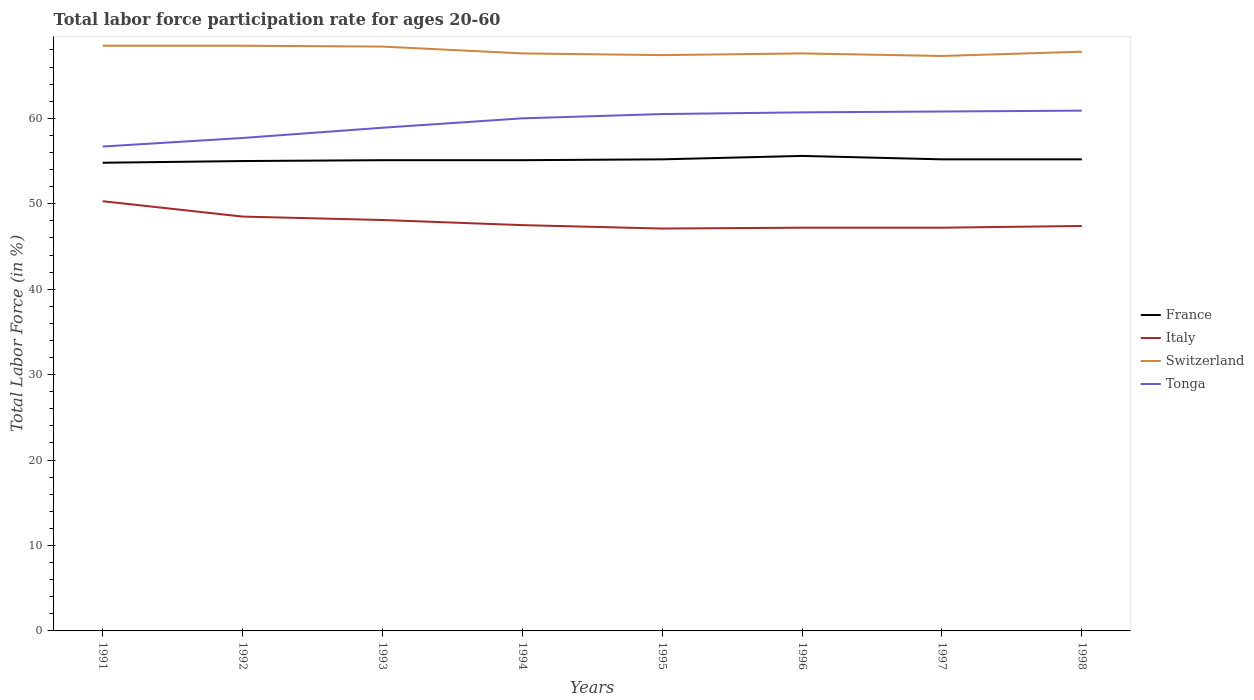Across all years, what is the maximum labor force participation rate in France?
Provide a short and direct response. 54.8. What is the total labor force participation rate in Switzerland in the graph?
Make the answer very short. -0.2. What is the difference between the highest and the second highest labor force participation rate in Switzerland?
Make the answer very short. 1.2. What is the difference between the highest and the lowest labor force participation rate in France?
Your answer should be compact. 4. Is the labor force participation rate in France strictly greater than the labor force participation rate in Italy over the years?
Provide a short and direct response. No. How many lines are there?
Your answer should be very brief. 4. What is the difference between two consecutive major ticks on the Y-axis?
Give a very brief answer. 10. Does the graph contain any zero values?
Your response must be concise. No. Where does the legend appear in the graph?
Your response must be concise. Center right. What is the title of the graph?
Make the answer very short. Total labor force participation rate for ages 20-60. What is the label or title of the X-axis?
Make the answer very short. Years. What is the label or title of the Y-axis?
Your answer should be compact. Total Labor Force (in %). What is the Total Labor Force (in %) in France in 1991?
Make the answer very short. 54.8. What is the Total Labor Force (in %) in Italy in 1991?
Provide a short and direct response. 50.3. What is the Total Labor Force (in %) of Switzerland in 1991?
Offer a very short reply. 68.5. What is the Total Labor Force (in %) of Tonga in 1991?
Make the answer very short. 56.7. What is the Total Labor Force (in %) of Italy in 1992?
Provide a short and direct response. 48.5. What is the Total Labor Force (in %) in Switzerland in 1992?
Keep it short and to the point. 68.5. What is the Total Labor Force (in %) in Tonga in 1992?
Offer a very short reply. 57.7. What is the Total Labor Force (in %) in France in 1993?
Your answer should be compact. 55.1. What is the Total Labor Force (in %) of Italy in 1993?
Offer a terse response. 48.1. What is the Total Labor Force (in %) of Switzerland in 1993?
Your response must be concise. 68.4. What is the Total Labor Force (in %) in Tonga in 1993?
Your response must be concise. 58.9. What is the Total Labor Force (in %) in France in 1994?
Provide a short and direct response. 55.1. What is the Total Labor Force (in %) in Italy in 1994?
Ensure brevity in your answer.  47.5. What is the Total Labor Force (in %) in Switzerland in 1994?
Make the answer very short. 67.6. What is the Total Labor Force (in %) in France in 1995?
Provide a succinct answer. 55.2. What is the Total Labor Force (in %) in Italy in 1995?
Offer a terse response. 47.1. What is the Total Labor Force (in %) of Switzerland in 1995?
Offer a terse response. 67.4. What is the Total Labor Force (in %) in Tonga in 1995?
Make the answer very short. 60.5. What is the Total Labor Force (in %) of France in 1996?
Provide a short and direct response. 55.6. What is the Total Labor Force (in %) in Italy in 1996?
Your answer should be very brief. 47.2. What is the Total Labor Force (in %) in Switzerland in 1996?
Your answer should be very brief. 67.6. What is the Total Labor Force (in %) of Tonga in 1996?
Give a very brief answer. 60.7. What is the Total Labor Force (in %) in France in 1997?
Offer a terse response. 55.2. What is the Total Labor Force (in %) in Italy in 1997?
Give a very brief answer. 47.2. What is the Total Labor Force (in %) of Switzerland in 1997?
Your response must be concise. 67.3. What is the Total Labor Force (in %) of Tonga in 1997?
Offer a very short reply. 60.8. What is the Total Labor Force (in %) of France in 1998?
Provide a succinct answer. 55.2. What is the Total Labor Force (in %) in Italy in 1998?
Your answer should be compact. 47.4. What is the Total Labor Force (in %) in Switzerland in 1998?
Your response must be concise. 67.8. What is the Total Labor Force (in %) of Tonga in 1998?
Ensure brevity in your answer.  60.9. Across all years, what is the maximum Total Labor Force (in %) of France?
Keep it short and to the point. 55.6. Across all years, what is the maximum Total Labor Force (in %) of Italy?
Give a very brief answer. 50.3. Across all years, what is the maximum Total Labor Force (in %) in Switzerland?
Provide a succinct answer. 68.5. Across all years, what is the maximum Total Labor Force (in %) of Tonga?
Offer a very short reply. 60.9. Across all years, what is the minimum Total Labor Force (in %) of France?
Ensure brevity in your answer.  54.8. Across all years, what is the minimum Total Labor Force (in %) of Italy?
Ensure brevity in your answer.  47.1. Across all years, what is the minimum Total Labor Force (in %) in Switzerland?
Offer a terse response. 67.3. Across all years, what is the minimum Total Labor Force (in %) in Tonga?
Give a very brief answer. 56.7. What is the total Total Labor Force (in %) of France in the graph?
Make the answer very short. 441.2. What is the total Total Labor Force (in %) in Italy in the graph?
Your answer should be very brief. 383.3. What is the total Total Labor Force (in %) in Switzerland in the graph?
Make the answer very short. 543.1. What is the total Total Labor Force (in %) in Tonga in the graph?
Keep it short and to the point. 476.2. What is the difference between the Total Labor Force (in %) of France in 1991 and that in 1992?
Keep it short and to the point. -0.2. What is the difference between the Total Labor Force (in %) in Italy in 1991 and that in 1992?
Ensure brevity in your answer.  1.8. What is the difference between the Total Labor Force (in %) of France in 1991 and that in 1993?
Your response must be concise. -0.3. What is the difference between the Total Labor Force (in %) of Tonga in 1991 and that in 1993?
Keep it short and to the point. -2.2. What is the difference between the Total Labor Force (in %) in France in 1991 and that in 1994?
Your answer should be compact. -0.3. What is the difference between the Total Labor Force (in %) of Italy in 1991 and that in 1995?
Offer a terse response. 3.2. What is the difference between the Total Labor Force (in %) of Switzerland in 1991 and that in 1995?
Your answer should be compact. 1.1. What is the difference between the Total Labor Force (in %) of France in 1991 and that in 1996?
Ensure brevity in your answer.  -0.8. What is the difference between the Total Labor Force (in %) of Italy in 1991 and that in 1996?
Give a very brief answer. 3.1. What is the difference between the Total Labor Force (in %) of Italy in 1991 and that in 1997?
Offer a terse response. 3.1. What is the difference between the Total Labor Force (in %) in Switzerland in 1991 and that in 1997?
Provide a short and direct response. 1.2. What is the difference between the Total Labor Force (in %) in Tonga in 1991 and that in 1997?
Keep it short and to the point. -4.1. What is the difference between the Total Labor Force (in %) in Switzerland in 1991 and that in 1998?
Give a very brief answer. 0.7. What is the difference between the Total Labor Force (in %) in Tonga in 1991 and that in 1998?
Provide a succinct answer. -4.2. What is the difference between the Total Labor Force (in %) in France in 1992 and that in 1993?
Your response must be concise. -0.1. What is the difference between the Total Labor Force (in %) of Italy in 1992 and that in 1994?
Your answer should be very brief. 1. What is the difference between the Total Labor Force (in %) of Tonga in 1992 and that in 1994?
Make the answer very short. -2.3. What is the difference between the Total Labor Force (in %) of France in 1992 and that in 1995?
Make the answer very short. -0.2. What is the difference between the Total Labor Force (in %) of France in 1992 and that in 1996?
Your answer should be very brief. -0.6. What is the difference between the Total Labor Force (in %) in Italy in 1992 and that in 1996?
Provide a short and direct response. 1.3. What is the difference between the Total Labor Force (in %) of Switzerland in 1992 and that in 1996?
Your answer should be compact. 0.9. What is the difference between the Total Labor Force (in %) in Italy in 1992 and that in 1997?
Your answer should be compact. 1.3. What is the difference between the Total Labor Force (in %) in Switzerland in 1992 and that in 1997?
Offer a very short reply. 1.2. What is the difference between the Total Labor Force (in %) of France in 1992 and that in 1998?
Keep it short and to the point. -0.2. What is the difference between the Total Labor Force (in %) of Italy in 1992 and that in 1998?
Ensure brevity in your answer.  1.1. What is the difference between the Total Labor Force (in %) in Switzerland in 1992 and that in 1998?
Offer a very short reply. 0.7. What is the difference between the Total Labor Force (in %) of Tonga in 1992 and that in 1998?
Ensure brevity in your answer.  -3.2. What is the difference between the Total Labor Force (in %) of France in 1993 and that in 1994?
Make the answer very short. 0. What is the difference between the Total Labor Force (in %) of Italy in 1993 and that in 1994?
Make the answer very short. 0.6. What is the difference between the Total Labor Force (in %) in Switzerland in 1993 and that in 1994?
Ensure brevity in your answer.  0.8. What is the difference between the Total Labor Force (in %) of France in 1993 and that in 1996?
Give a very brief answer. -0.5. What is the difference between the Total Labor Force (in %) in Italy in 1993 and that in 1996?
Give a very brief answer. 0.9. What is the difference between the Total Labor Force (in %) in Tonga in 1993 and that in 1996?
Offer a terse response. -1.8. What is the difference between the Total Labor Force (in %) in France in 1993 and that in 1997?
Offer a terse response. -0.1. What is the difference between the Total Labor Force (in %) of Switzerland in 1993 and that in 1997?
Offer a terse response. 1.1. What is the difference between the Total Labor Force (in %) of Tonga in 1993 and that in 1997?
Your answer should be compact. -1.9. What is the difference between the Total Labor Force (in %) in Italy in 1993 and that in 1998?
Your answer should be very brief. 0.7. What is the difference between the Total Labor Force (in %) of France in 1994 and that in 1995?
Offer a very short reply. -0.1. What is the difference between the Total Labor Force (in %) of Italy in 1994 and that in 1995?
Offer a terse response. 0.4. What is the difference between the Total Labor Force (in %) of Switzerland in 1994 and that in 1995?
Offer a very short reply. 0.2. What is the difference between the Total Labor Force (in %) of Tonga in 1994 and that in 1995?
Provide a short and direct response. -0.5. What is the difference between the Total Labor Force (in %) in France in 1994 and that in 1996?
Provide a short and direct response. -0.5. What is the difference between the Total Labor Force (in %) of Italy in 1994 and that in 1996?
Make the answer very short. 0.3. What is the difference between the Total Labor Force (in %) in Switzerland in 1994 and that in 1996?
Offer a terse response. 0. What is the difference between the Total Labor Force (in %) of Tonga in 1994 and that in 1996?
Provide a short and direct response. -0.7. What is the difference between the Total Labor Force (in %) in France in 1994 and that in 1997?
Provide a short and direct response. -0.1. What is the difference between the Total Labor Force (in %) in Italy in 1994 and that in 1997?
Make the answer very short. 0.3. What is the difference between the Total Labor Force (in %) in Switzerland in 1994 and that in 1997?
Give a very brief answer. 0.3. What is the difference between the Total Labor Force (in %) of Tonga in 1994 and that in 1997?
Your response must be concise. -0.8. What is the difference between the Total Labor Force (in %) in France in 1994 and that in 1998?
Offer a very short reply. -0.1. What is the difference between the Total Labor Force (in %) in Switzerland in 1994 and that in 1998?
Offer a terse response. -0.2. What is the difference between the Total Labor Force (in %) of Tonga in 1994 and that in 1998?
Keep it short and to the point. -0.9. What is the difference between the Total Labor Force (in %) of France in 1995 and that in 1996?
Make the answer very short. -0.4. What is the difference between the Total Labor Force (in %) in Italy in 1995 and that in 1996?
Give a very brief answer. -0.1. What is the difference between the Total Labor Force (in %) in Switzerland in 1995 and that in 1996?
Your answer should be compact. -0.2. What is the difference between the Total Labor Force (in %) of Tonga in 1995 and that in 1996?
Offer a very short reply. -0.2. What is the difference between the Total Labor Force (in %) of France in 1995 and that in 1997?
Offer a terse response. 0. What is the difference between the Total Labor Force (in %) of Tonga in 1995 and that in 1997?
Offer a very short reply. -0.3. What is the difference between the Total Labor Force (in %) in Italy in 1995 and that in 1998?
Your answer should be very brief. -0.3. What is the difference between the Total Labor Force (in %) in Switzerland in 1995 and that in 1998?
Ensure brevity in your answer.  -0.4. What is the difference between the Total Labor Force (in %) in Tonga in 1995 and that in 1998?
Provide a short and direct response. -0.4. What is the difference between the Total Labor Force (in %) of France in 1996 and that in 1997?
Keep it short and to the point. 0.4. What is the difference between the Total Labor Force (in %) in Tonga in 1996 and that in 1997?
Provide a succinct answer. -0.1. What is the difference between the Total Labor Force (in %) in Italy in 1996 and that in 1998?
Make the answer very short. -0.2. What is the difference between the Total Labor Force (in %) of Switzerland in 1996 and that in 1998?
Offer a terse response. -0.2. What is the difference between the Total Labor Force (in %) of Switzerland in 1997 and that in 1998?
Your answer should be compact. -0.5. What is the difference between the Total Labor Force (in %) of Tonga in 1997 and that in 1998?
Provide a succinct answer. -0.1. What is the difference between the Total Labor Force (in %) of France in 1991 and the Total Labor Force (in %) of Italy in 1992?
Keep it short and to the point. 6.3. What is the difference between the Total Labor Force (in %) of France in 1991 and the Total Labor Force (in %) of Switzerland in 1992?
Your response must be concise. -13.7. What is the difference between the Total Labor Force (in %) of Italy in 1991 and the Total Labor Force (in %) of Switzerland in 1992?
Your response must be concise. -18.2. What is the difference between the Total Labor Force (in %) in Switzerland in 1991 and the Total Labor Force (in %) in Tonga in 1992?
Your answer should be very brief. 10.8. What is the difference between the Total Labor Force (in %) of France in 1991 and the Total Labor Force (in %) of Italy in 1993?
Offer a terse response. 6.7. What is the difference between the Total Labor Force (in %) in France in 1991 and the Total Labor Force (in %) in Switzerland in 1993?
Provide a succinct answer. -13.6. What is the difference between the Total Labor Force (in %) of Italy in 1991 and the Total Labor Force (in %) of Switzerland in 1993?
Keep it short and to the point. -18.1. What is the difference between the Total Labor Force (in %) of Switzerland in 1991 and the Total Labor Force (in %) of Tonga in 1993?
Provide a succinct answer. 9.6. What is the difference between the Total Labor Force (in %) of France in 1991 and the Total Labor Force (in %) of Italy in 1994?
Your answer should be compact. 7.3. What is the difference between the Total Labor Force (in %) in France in 1991 and the Total Labor Force (in %) in Tonga in 1994?
Your response must be concise. -5.2. What is the difference between the Total Labor Force (in %) in Italy in 1991 and the Total Labor Force (in %) in Switzerland in 1994?
Your response must be concise. -17.3. What is the difference between the Total Labor Force (in %) of France in 1991 and the Total Labor Force (in %) of Switzerland in 1995?
Your answer should be compact. -12.6. What is the difference between the Total Labor Force (in %) of France in 1991 and the Total Labor Force (in %) of Tonga in 1995?
Provide a succinct answer. -5.7. What is the difference between the Total Labor Force (in %) of Italy in 1991 and the Total Labor Force (in %) of Switzerland in 1995?
Offer a terse response. -17.1. What is the difference between the Total Labor Force (in %) of France in 1991 and the Total Labor Force (in %) of Italy in 1996?
Make the answer very short. 7.6. What is the difference between the Total Labor Force (in %) in France in 1991 and the Total Labor Force (in %) in Switzerland in 1996?
Offer a very short reply. -12.8. What is the difference between the Total Labor Force (in %) of Italy in 1991 and the Total Labor Force (in %) of Switzerland in 1996?
Keep it short and to the point. -17.3. What is the difference between the Total Labor Force (in %) in Italy in 1991 and the Total Labor Force (in %) in Tonga in 1996?
Give a very brief answer. -10.4. What is the difference between the Total Labor Force (in %) in France in 1991 and the Total Labor Force (in %) in Italy in 1998?
Offer a terse response. 7.4. What is the difference between the Total Labor Force (in %) of Italy in 1991 and the Total Labor Force (in %) of Switzerland in 1998?
Provide a succinct answer. -17.5. What is the difference between the Total Labor Force (in %) in France in 1992 and the Total Labor Force (in %) in Italy in 1993?
Offer a very short reply. 6.9. What is the difference between the Total Labor Force (in %) in Italy in 1992 and the Total Labor Force (in %) in Switzerland in 1993?
Give a very brief answer. -19.9. What is the difference between the Total Labor Force (in %) of France in 1992 and the Total Labor Force (in %) of Switzerland in 1994?
Your answer should be compact. -12.6. What is the difference between the Total Labor Force (in %) in Italy in 1992 and the Total Labor Force (in %) in Switzerland in 1994?
Give a very brief answer. -19.1. What is the difference between the Total Labor Force (in %) of Italy in 1992 and the Total Labor Force (in %) of Tonga in 1994?
Make the answer very short. -11.5. What is the difference between the Total Labor Force (in %) of France in 1992 and the Total Labor Force (in %) of Italy in 1995?
Offer a very short reply. 7.9. What is the difference between the Total Labor Force (in %) of Italy in 1992 and the Total Labor Force (in %) of Switzerland in 1995?
Your answer should be compact. -18.9. What is the difference between the Total Labor Force (in %) of Italy in 1992 and the Total Labor Force (in %) of Tonga in 1995?
Keep it short and to the point. -12. What is the difference between the Total Labor Force (in %) of France in 1992 and the Total Labor Force (in %) of Italy in 1996?
Your answer should be very brief. 7.8. What is the difference between the Total Labor Force (in %) of France in 1992 and the Total Labor Force (in %) of Tonga in 1996?
Offer a very short reply. -5.7. What is the difference between the Total Labor Force (in %) of Italy in 1992 and the Total Labor Force (in %) of Switzerland in 1996?
Ensure brevity in your answer.  -19.1. What is the difference between the Total Labor Force (in %) of Italy in 1992 and the Total Labor Force (in %) of Tonga in 1996?
Ensure brevity in your answer.  -12.2. What is the difference between the Total Labor Force (in %) of France in 1992 and the Total Labor Force (in %) of Switzerland in 1997?
Give a very brief answer. -12.3. What is the difference between the Total Labor Force (in %) in France in 1992 and the Total Labor Force (in %) in Tonga in 1997?
Provide a short and direct response. -5.8. What is the difference between the Total Labor Force (in %) of Italy in 1992 and the Total Labor Force (in %) of Switzerland in 1997?
Provide a short and direct response. -18.8. What is the difference between the Total Labor Force (in %) of France in 1992 and the Total Labor Force (in %) of Switzerland in 1998?
Make the answer very short. -12.8. What is the difference between the Total Labor Force (in %) of France in 1992 and the Total Labor Force (in %) of Tonga in 1998?
Make the answer very short. -5.9. What is the difference between the Total Labor Force (in %) of Italy in 1992 and the Total Labor Force (in %) of Switzerland in 1998?
Provide a succinct answer. -19.3. What is the difference between the Total Labor Force (in %) of Switzerland in 1992 and the Total Labor Force (in %) of Tonga in 1998?
Your response must be concise. 7.6. What is the difference between the Total Labor Force (in %) of France in 1993 and the Total Labor Force (in %) of Italy in 1994?
Offer a very short reply. 7.6. What is the difference between the Total Labor Force (in %) in Italy in 1993 and the Total Labor Force (in %) in Switzerland in 1994?
Ensure brevity in your answer.  -19.5. What is the difference between the Total Labor Force (in %) in Switzerland in 1993 and the Total Labor Force (in %) in Tonga in 1994?
Offer a terse response. 8.4. What is the difference between the Total Labor Force (in %) of France in 1993 and the Total Labor Force (in %) of Italy in 1995?
Offer a very short reply. 8. What is the difference between the Total Labor Force (in %) of France in 1993 and the Total Labor Force (in %) of Switzerland in 1995?
Ensure brevity in your answer.  -12.3. What is the difference between the Total Labor Force (in %) in Italy in 1993 and the Total Labor Force (in %) in Switzerland in 1995?
Offer a terse response. -19.3. What is the difference between the Total Labor Force (in %) of Italy in 1993 and the Total Labor Force (in %) of Tonga in 1995?
Give a very brief answer. -12.4. What is the difference between the Total Labor Force (in %) in Switzerland in 1993 and the Total Labor Force (in %) in Tonga in 1995?
Make the answer very short. 7.9. What is the difference between the Total Labor Force (in %) of France in 1993 and the Total Labor Force (in %) of Italy in 1996?
Keep it short and to the point. 7.9. What is the difference between the Total Labor Force (in %) in France in 1993 and the Total Labor Force (in %) in Tonga in 1996?
Ensure brevity in your answer.  -5.6. What is the difference between the Total Labor Force (in %) of Italy in 1993 and the Total Labor Force (in %) of Switzerland in 1996?
Provide a succinct answer. -19.5. What is the difference between the Total Labor Force (in %) of Switzerland in 1993 and the Total Labor Force (in %) of Tonga in 1996?
Offer a very short reply. 7.7. What is the difference between the Total Labor Force (in %) in France in 1993 and the Total Labor Force (in %) in Switzerland in 1997?
Make the answer very short. -12.2. What is the difference between the Total Labor Force (in %) of France in 1993 and the Total Labor Force (in %) of Tonga in 1997?
Keep it short and to the point. -5.7. What is the difference between the Total Labor Force (in %) in Italy in 1993 and the Total Labor Force (in %) in Switzerland in 1997?
Provide a succinct answer. -19.2. What is the difference between the Total Labor Force (in %) in Italy in 1993 and the Total Labor Force (in %) in Tonga in 1997?
Provide a short and direct response. -12.7. What is the difference between the Total Labor Force (in %) in Switzerland in 1993 and the Total Labor Force (in %) in Tonga in 1997?
Your answer should be very brief. 7.6. What is the difference between the Total Labor Force (in %) of France in 1993 and the Total Labor Force (in %) of Switzerland in 1998?
Ensure brevity in your answer.  -12.7. What is the difference between the Total Labor Force (in %) of Italy in 1993 and the Total Labor Force (in %) of Switzerland in 1998?
Make the answer very short. -19.7. What is the difference between the Total Labor Force (in %) of France in 1994 and the Total Labor Force (in %) of Italy in 1995?
Make the answer very short. 8. What is the difference between the Total Labor Force (in %) of Italy in 1994 and the Total Labor Force (in %) of Switzerland in 1995?
Keep it short and to the point. -19.9. What is the difference between the Total Labor Force (in %) in Switzerland in 1994 and the Total Labor Force (in %) in Tonga in 1995?
Offer a very short reply. 7.1. What is the difference between the Total Labor Force (in %) of Italy in 1994 and the Total Labor Force (in %) of Switzerland in 1996?
Your answer should be very brief. -20.1. What is the difference between the Total Labor Force (in %) of Italy in 1994 and the Total Labor Force (in %) of Tonga in 1996?
Offer a very short reply. -13.2. What is the difference between the Total Labor Force (in %) of Switzerland in 1994 and the Total Labor Force (in %) of Tonga in 1996?
Your response must be concise. 6.9. What is the difference between the Total Labor Force (in %) in France in 1994 and the Total Labor Force (in %) in Switzerland in 1997?
Offer a terse response. -12.2. What is the difference between the Total Labor Force (in %) of Italy in 1994 and the Total Labor Force (in %) of Switzerland in 1997?
Make the answer very short. -19.8. What is the difference between the Total Labor Force (in %) of Italy in 1994 and the Total Labor Force (in %) of Tonga in 1997?
Provide a succinct answer. -13.3. What is the difference between the Total Labor Force (in %) in France in 1994 and the Total Labor Force (in %) in Italy in 1998?
Your answer should be compact. 7.7. What is the difference between the Total Labor Force (in %) in France in 1994 and the Total Labor Force (in %) in Switzerland in 1998?
Ensure brevity in your answer.  -12.7. What is the difference between the Total Labor Force (in %) in France in 1994 and the Total Labor Force (in %) in Tonga in 1998?
Offer a terse response. -5.8. What is the difference between the Total Labor Force (in %) of Italy in 1994 and the Total Labor Force (in %) of Switzerland in 1998?
Keep it short and to the point. -20.3. What is the difference between the Total Labor Force (in %) of France in 1995 and the Total Labor Force (in %) of Italy in 1996?
Offer a very short reply. 8. What is the difference between the Total Labor Force (in %) in France in 1995 and the Total Labor Force (in %) in Tonga in 1996?
Ensure brevity in your answer.  -5.5. What is the difference between the Total Labor Force (in %) of Italy in 1995 and the Total Labor Force (in %) of Switzerland in 1996?
Make the answer very short. -20.5. What is the difference between the Total Labor Force (in %) of Italy in 1995 and the Total Labor Force (in %) of Tonga in 1996?
Ensure brevity in your answer.  -13.6. What is the difference between the Total Labor Force (in %) in Italy in 1995 and the Total Labor Force (in %) in Switzerland in 1997?
Your answer should be very brief. -20.2. What is the difference between the Total Labor Force (in %) of Italy in 1995 and the Total Labor Force (in %) of Tonga in 1997?
Ensure brevity in your answer.  -13.7. What is the difference between the Total Labor Force (in %) of Switzerland in 1995 and the Total Labor Force (in %) of Tonga in 1997?
Give a very brief answer. 6.6. What is the difference between the Total Labor Force (in %) in France in 1995 and the Total Labor Force (in %) in Italy in 1998?
Your response must be concise. 7.8. What is the difference between the Total Labor Force (in %) of France in 1995 and the Total Labor Force (in %) of Tonga in 1998?
Give a very brief answer. -5.7. What is the difference between the Total Labor Force (in %) in Italy in 1995 and the Total Labor Force (in %) in Switzerland in 1998?
Provide a short and direct response. -20.7. What is the difference between the Total Labor Force (in %) in Italy in 1995 and the Total Labor Force (in %) in Tonga in 1998?
Give a very brief answer. -13.8. What is the difference between the Total Labor Force (in %) in Switzerland in 1995 and the Total Labor Force (in %) in Tonga in 1998?
Your answer should be very brief. 6.5. What is the difference between the Total Labor Force (in %) in France in 1996 and the Total Labor Force (in %) in Italy in 1997?
Ensure brevity in your answer.  8.4. What is the difference between the Total Labor Force (in %) in France in 1996 and the Total Labor Force (in %) in Tonga in 1997?
Your answer should be very brief. -5.2. What is the difference between the Total Labor Force (in %) of Italy in 1996 and the Total Labor Force (in %) of Switzerland in 1997?
Ensure brevity in your answer.  -20.1. What is the difference between the Total Labor Force (in %) of Italy in 1996 and the Total Labor Force (in %) of Tonga in 1997?
Offer a very short reply. -13.6. What is the difference between the Total Labor Force (in %) in Switzerland in 1996 and the Total Labor Force (in %) in Tonga in 1997?
Keep it short and to the point. 6.8. What is the difference between the Total Labor Force (in %) of France in 1996 and the Total Labor Force (in %) of Tonga in 1998?
Your answer should be compact. -5.3. What is the difference between the Total Labor Force (in %) in Italy in 1996 and the Total Labor Force (in %) in Switzerland in 1998?
Provide a short and direct response. -20.6. What is the difference between the Total Labor Force (in %) in Italy in 1996 and the Total Labor Force (in %) in Tonga in 1998?
Ensure brevity in your answer.  -13.7. What is the difference between the Total Labor Force (in %) in Switzerland in 1996 and the Total Labor Force (in %) in Tonga in 1998?
Ensure brevity in your answer.  6.7. What is the difference between the Total Labor Force (in %) in France in 1997 and the Total Labor Force (in %) in Italy in 1998?
Keep it short and to the point. 7.8. What is the difference between the Total Labor Force (in %) in France in 1997 and the Total Labor Force (in %) in Switzerland in 1998?
Keep it short and to the point. -12.6. What is the difference between the Total Labor Force (in %) in Italy in 1997 and the Total Labor Force (in %) in Switzerland in 1998?
Your answer should be compact. -20.6. What is the difference between the Total Labor Force (in %) of Italy in 1997 and the Total Labor Force (in %) of Tonga in 1998?
Your answer should be compact. -13.7. What is the difference between the Total Labor Force (in %) of Switzerland in 1997 and the Total Labor Force (in %) of Tonga in 1998?
Offer a very short reply. 6.4. What is the average Total Labor Force (in %) of France per year?
Offer a terse response. 55.15. What is the average Total Labor Force (in %) in Italy per year?
Keep it short and to the point. 47.91. What is the average Total Labor Force (in %) of Switzerland per year?
Your answer should be very brief. 67.89. What is the average Total Labor Force (in %) in Tonga per year?
Keep it short and to the point. 59.52. In the year 1991, what is the difference between the Total Labor Force (in %) in France and Total Labor Force (in %) in Italy?
Provide a succinct answer. 4.5. In the year 1991, what is the difference between the Total Labor Force (in %) of France and Total Labor Force (in %) of Switzerland?
Keep it short and to the point. -13.7. In the year 1991, what is the difference between the Total Labor Force (in %) in Italy and Total Labor Force (in %) in Switzerland?
Make the answer very short. -18.2. In the year 1991, what is the difference between the Total Labor Force (in %) in Italy and Total Labor Force (in %) in Tonga?
Ensure brevity in your answer.  -6.4. In the year 1991, what is the difference between the Total Labor Force (in %) in Switzerland and Total Labor Force (in %) in Tonga?
Provide a succinct answer. 11.8. In the year 1992, what is the difference between the Total Labor Force (in %) of France and Total Labor Force (in %) of Italy?
Keep it short and to the point. 6.5. In the year 1992, what is the difference between the Total Labor Force (in %) of Italy and Total Labor Force (in %) of Tonga?
Make the answer very short. -9.2. In the year 1992, what is the difference between the Total Labor Force (in %) in Switzerland and Total Labor Force (in %) in Tonga?
Keep it short and to the point. 10.8. In the year 1993, what is the difference between the Total Labor Force (in %) of France and Total Labor Force (in %) of Switzerland?
Ensure brevity in your answer.  -13.3. In the year 1993, what is the difference between the Total Labor Force (in %) of Italy and Total Labor Force (in %) of Switzerland?
Give a very brief answer. -20.3. In the year 1994, what is the difference between the Total Labor Force (in %) of Italy and Total Labor Force (in %) of Switzerland?
Offer a terse response. -20.1. In the year 1995, what is the difference between the Total Labor Force (in %) in France and Total Labor Force (in %) in Switzerland?
Your answer should be very brief. -12.2. In the year 1995, what is the difference between the Total Labor Force (in %) in Italy and Total Labor Force (in %) in Switzerland?
Keep it short and to the point. -20.3. In the year 1995, what is the difference between the Total Labor Force (in %) in Switzerland and Total Labor Force (in %) in Tonga?
Your answer should be very brief. 6.9. In the year 1996, what is the difference between the Total Labor Force (in %) in France and Total Labor Force (in %) in Tonga?
Provide a short and direct response. -5.1. In the year 1996, what is the difference between the Total Labor Force (in %) of Italy and Total Labor Force (in %) of Switzerland?
Your answer should be compact. -20.4. In the year 1996, what is the difference between the Total Labor Force (in %) in Switzerland and Total Labor Force (in %) in Tonga?
Provide a short and direct response. 6.9. In the year 1997, what is the difference between the Total Labor Force (in %) of Italy and Total Labor Force (in %) of Switzerland?
Offer a terse response. -20.1. In the year 1998, what is the difference between the Total Labor Force (in %) in France and Total Labor Force (in %) in Switzerland?
Keep it short and to the point. -12.6. In the year 1998, what is the difference between the Total Labor Force (in %) in Italy and Total Labor Force (in %) in Switzerland?
Offer a very short reply. -20.4. In the year 1998, what is the difference between the Total Labor Force (in %) in Switzerland and Total Labor Force (in %) in Tonga?
Your answer should be compact. 6.9. What is the ratio of the Total Labor Force (in %) of France in 1991 to that in 1992?
Provide a short and direct response. 1. What is the ratio of the Total Labor Force (in %) of Italy in 1991 to that in 1992?
Ensure brevity in your answer.  1.04. What is the ratio of the Total Labor Force (in %) in Switzerland in 1991 to that in 1992?
Your response must be concise. 1. What is the ratio of the Total Labor Force (in %) in Tonga in 1991 to that in 1992?
Offer a very short reply. 0.98. What is the ratio of the Total Labor Force (in %) of France in 1991 to that in 1993?
Provide a short and direct response. 0.99. What is the ratio of the Total Labor Force (in %) of Italy in 1991 to that in 1993?
Offer a terse response. 1.05. What is the ratio of the Total Labor Force (in %) in Switzerland in 1991 to that in 1993?
Your answer should be compact. 1. What is the ratio of the Total Labor Force (in %) of Tonga in 1991 to that in 1993?
Provide a short and direct response. 0.96. What is the ratio of the Total Labor Force (in %) of France in 1991 to that in 1994?
Your answer should be very brief. 0.99. What is the ratio of the Total Labor Force (in %) in Italy in 1991 to that in 1994?
Offer a very short reply. 1.06. What is the ratio of the Total Labor Force (in %) of Switzerland in 1991 to that in 1994?
Keep it short and to the point. 1.01. What is the ratio of the Total Labor Force (in %) in Tonga in 1991 to that in 1994?
Your answer should be very brief. 0.94. What is the ratio of the Total Labor Force (in %) in France in 1991 to that in 1995?
Ensure brevity in your answer.  0.99. What is the ratio of the Total Labor Force (in %) in Italy in 1991 to that in 1995?
Offer a very short reply. 1.07. What is the ratio of the Total Labor Force (in %) in Switzerland in 1991 to that in 1995?
Keep it short and to the point. 1.02. What is the ratio of the Total Labor Force (in %) of Tonga in 1991 to that in 1995?
Provide a short and direct response. 0.94. What is the ratio of the Total Labor Force (in %) in France in 1991 to that in 1996?
Ensure brevity in your answer.  0.99. What is the ratio of the Total Labor Force (in %) of Italy in 1991 to that in 1996?
Your response must be concise. 1.07. What is the ratio of the Total Labor Force (in %) of Switzerland in 1991 to that in 1996?
Offer a very short reply. 1.01. What is the ratio of the Total Labor Force (in %) in Tonga in 1991 to that in 1996?
Give a very brief answer. 0.93. What is the ratio of the Total Labor Force (in %) in France in 1991 to that in 1997?
Offer a very short reply. 0.99. What is the ratio of the Total Labor Force (in %) in Italy in 1991 to that in 1997?
Your answer should be very brief. 1.07. What is the ratio of the Total Labor Force (in %) in Switzerland in 1991 to that in 1997?
Your answer should be compact. 1.02. What is the ratio of the Total Labor Force (in %) of Tonga in 1991 to that in 1997?
Provide a short and direct response. 0.93. What is the ratio of the Total Labor Force (in %) of Italy in 1991 to that in 1998?
Your answer should be very brief. 1.06. What is the ratio of the Total Labor Force (in %) in Switzerland in 1991 to that in 1998?
Offer a terse response. 1.01. What is the ratio of the Total Labor Force (in %) in Tonga in 1991 to that in 1998?
Give a very brief answer. 0.93. What is the ratio of the Total Labor Force (in %) in Italy in 1992 to that in 1993?
Offer a very short reply. 1.01. What is the ratio of the Total Labor Force (in %) in Switzerland in 1992 to that in 1993?
Your answer should be compact. 1. What is the ratio of the Total Labor Force (in %) of Tonga in 1992 to that in 1993?
Make the answer very short. 0.98. What is the ratio of the Total Labor Force (in %) in France in 1992 to that in 1994?
Ensure brevity in your answer.  1. What is the ratio of the Total Labor Force (in %) in Italy in 1992 to that in 1994?
Provide a succinct answer. 1.02. What is the ratio of the Total Labor Force (in %) in Switzerland in 1992 to that in 1994?
Offer a terse response. 1.01. What is the ratio of the Total Labor Force (in %) in Tonga in 1992 to that in 1994?
Offer a very short reply. 0.96. What is the ratio of the Total Labor Force (in %) of France in 1992 to that in 1995?
Make the answer very short. 1. What is the ratio of the Total Labor Force (in %) of Italy in 1992 to that in 1995?
Give a very brief answer. 1.03. What is the ratio of the Total Labor Force (in %) of Switzerland in 1992 to that in 1995?
Give a very brief answer. 1.02. What is the ratio of the Total Labor Force (in %) of Tonga in 1992 to that in 1995?
Your answer should be very brief. 0.95. What is the ratio of the Total Labor Force (in %) in France in 1992 to that in 1996?
Offer a very short reply. 0.99. What is the ratio of the Total Labor Force (in %) of Italy in 1992 to that in 1996?
Offer a terse response. 1.03. What is the ratio of the Total Labor Force (in %) of Switzerland in 1992 to that in 1996?
Give a very brief answer. 1.01. What is the ratio of the Total Labor Force (in %) in Tonga in 1992 to that in 1996?
Offer a terse response. 0.95. What is the ratio of the Total Labor Force (in %) of Italy in 1992 to that in 1997?
Provide a succinct answer. 1.03. What is the ratio of the Total Labor Force (in %) of Switzerland in 1992 to that in 1997?
Provide a short and direct response. 1.02. What is the ratio of the Total Labor Force (in %) of Tonga in 1992 to that in 1997?
Ensure brevity in your answer.  0.95. What is the ratio of the Total Labor Force (in %) in France in 1992 to that in 1998?
Keep it short and to the point. 1. What is the ratio of the Total Labor Force (in %) in Italy in 1992 to that in 1998?
Offer a very short reply. 1.02. What is the ratio of the Total Labor Force (in %) of Switzerland in 1992 to that in 1998?
Offer a terse response. 1.01. What is the ratio of the Total Labor Force (in %) in Tonga in 1992 to that in 1998?
Provide a succinct answer. 0.95. What is the ratio of the Total Labor Force (in %) of France in 1993 to that in 1994?
Provide a succinct answer. 1. What is the ratio of the Total Labor Force (in %) of Italy in 1993 to that in 1994?
Your response must be concise. 1.01. What is the ratio of the Total Labor Force (in %) of Switzerland in 1993 to that in 1994?
Offer a terse response. 1.01. What is the ratio of the Total Labor Force (in %) of Tonga in 1993 to that in 1994?
Your answer should be compact. 0.98. What is the ratio of the Total Labor Force (in %) of Italy in 1993 to that in 1995?
Make the answer very short. 1.02. What is the ratio of the Total Labor Force (in %) in Switzerland in 1993 to that in 1995?
Your answer should be very brief. 1.01. What is the ratio of the Total Labor Force (in %) of Tonga in 1993 to that in 1995?
Ensure brevity in your answer.  0.97. What is the ratio of the Total Labor Force (in %) of Italy in 1993 to that in 1996?
Your response must be concise. 1.02. What is the ratio of the Total Labor Force (in %) in Switzerland in 1993 to that in 1996?
Keep it short and to the point. 1.01. What is the ratio of the Total Labor Force (in %) in Tonga in 1993 to that in 1996?
Keep it short and to the point. 0.97. What is the ratio of the Total Labor Force (in %) in Italy in 1993 to that in 1997?
Ensure brevity in your answer.  1.02. What is the ratio of the Total Labor Force (in %) in Switzerland in 1993 to that in 1997?
Provide a succinct answer. 1.02. What is the ratio of the Total Labor Force (in %) of Tonga in 1993 to that in 1997?
Make the answer very short. 0.97. What is the ratio of the Total Labor Force (in %) of Italy in 1993 to that in 1998?
Give a very brief answer. 1.01. What is the ratio of the Total Labor Force (in %) in Switzerland in 1993 to that in 1998?
Keep it short and to the point. 1.01. What is the ratio of the Total Labor Force (in %) in Tonga in 1993 to that in 1998?
Offer a terse response. 0.97. What is the ratio of the Total Labor Force (in %) in Italy in 1994 to that in 1995?
Offer a terse response. 1.01. What is the ratio of the Total Labor Force (in %) of Italy in 1994 to that in 1996?
Keep it short and to the point. 1.01. What is the ratio of the Total Labor Force (in %) in Tonga in 1994 to that in 1996?
Your answer should be compact. 0.99. What is the ratio of the Total Labor Force (in %) in Italy in 1994 to that in 1997?
Make the answer very short. 1.01. What is the ratio of the Total Labor Force (in %) in Switzerland in 1994 to that in 1997?
Your answer should be very brief. 1. What is the ratio of the Total Labor Force (in %) of Italy in 1994 to that in 1998?
Provide a succinct answer. 1. What is the ratio of the Total Labor Force (in %) of Switzerland in 1994 to that in 1998?
Keep it short and to the point. 1. What is the ratio of the Total Labor Force (in %) in Tonga in 1994 to that in 1998?
Offer a terse response. 0.99. What is the ratio of the Total Labor Force (in %) of Italy in 1995 to that in 1996?
Your answer should be very brief. 1. What is the ratio of the Total Labor Force (in %) in Switzerland in 1995 to that in 1996?
Your answer should be very brief. 1. What is the ratio of the Total Labor Force (in %) in France in 1995 to that in 1997?
Provide a succinct answer. 1. What is the ratio of the Total Labor Force (in %) in Tonga in 1995 to that in 1997?
Provide a succinct answer. 1. What is the ratio of the Total Labor Force (in %) in France in 1995 to that in 1998?
Your response must be concise. 1. What is the ratio of the Total Labor Force (in %) in Italy in 1995 to that in 1998?
Keep it short and to the point. 0.99. What is the ratio of the Total Labor Force (in %) of Switzerland in 1995 to that in 1998?
Your answer should be compact. 0.99. What is the ratio of the Total Labor Force (in %) in France in 1996 to that in 1997?
Your response must be concise. 1.01. What is the ratio of the Total Labor Force (in %) of Tonga in 1996 to that in 1997?
Give a very brief answer. 1. What is the ratio of the Total Labor Force (in %) of France in 1996 to that in 1998?
Ensure brevity in your answer.  1.01. What is the difference between the highest and the second highest Total Labor Force (in %) of France?
Provide a short and direct response. 0.4. What is the difference between the highest and the second highest Total Labor Force (in %) in Switzerland?
Your answer should be very brief. 0. What is the difference between the highest and the lowest Total Labor Force (in %) in Italy?
Your answer should be very brief. 3.2. 